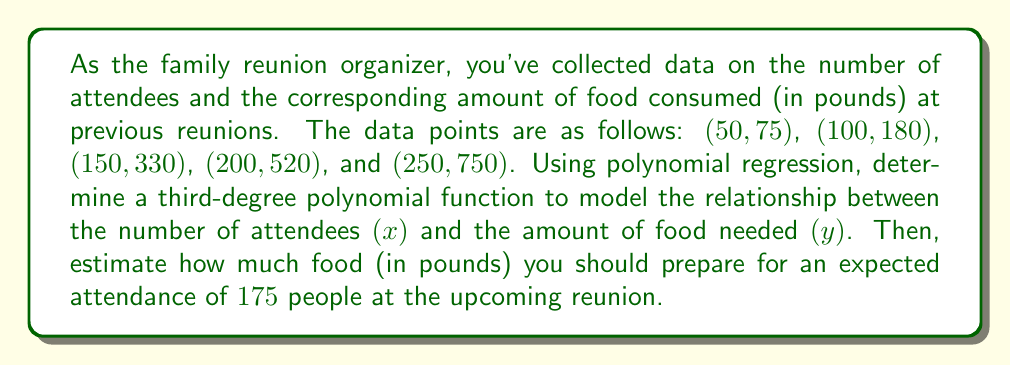Solve this math problem. 1. We need to find a third-degree polynomial of the form:
   $$y = ax^3 + bx^2 + cx + d$$

2. Using a polynomial regression calculator or software, we input the given data points to find the coefficients a, b, c, and d.

3. The resulting polynomial function is:
   $$y = 0.00008x^3 - 0.0164x^2 + 2.516x - 48.6$$

4. To estimate the amount of food needed for 175 attendees, we substitute x = 175 into our function:

   $$\begin{align}
   y &= 0.00008(175)^3 - 0.0164(175)^2 + 2.516(175) - 48.6 \\
   &= 0.00008(5359375) - 0.0164(30625) + 2.516(175) - 48.6 \\
   &= 428.75 - 502.25 + 440.3 - 48.6 \\
   &= 318.2
   \end{align}$$

5. Round the result to the nearest whole number, as we can't prepare fractional pounds of food.
Answer: 318 pounds 